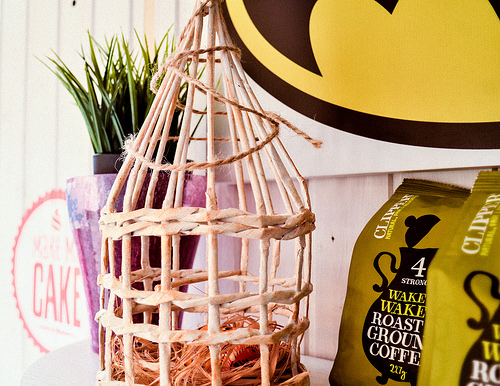<image>
Can you confirm if the birdhouse is in front of the coffee? Yes. The birdhouse is positioned in front of the coffee, appearing closer to the camera viewpoint. 